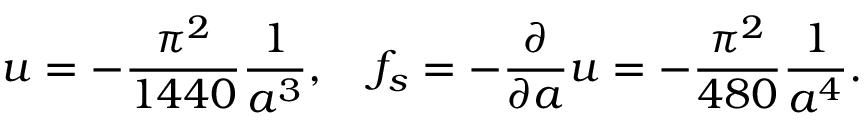Convert formula to latex. <formula><loc_0><loc_0><loc_500><loc_500>u = - { \frac { \pi ^ { 2 } } { 1 4 4 0 } } { \frac { 1 } { a ^ { 3 } } } , \quad f _ { s } = - { \frac { \partial } { \partial a } } u = - { \frac { \pi ^ { 2 } } { 4 8 0 } } { \frac { 1 } { a ^ { 4 } } } .</formula> 